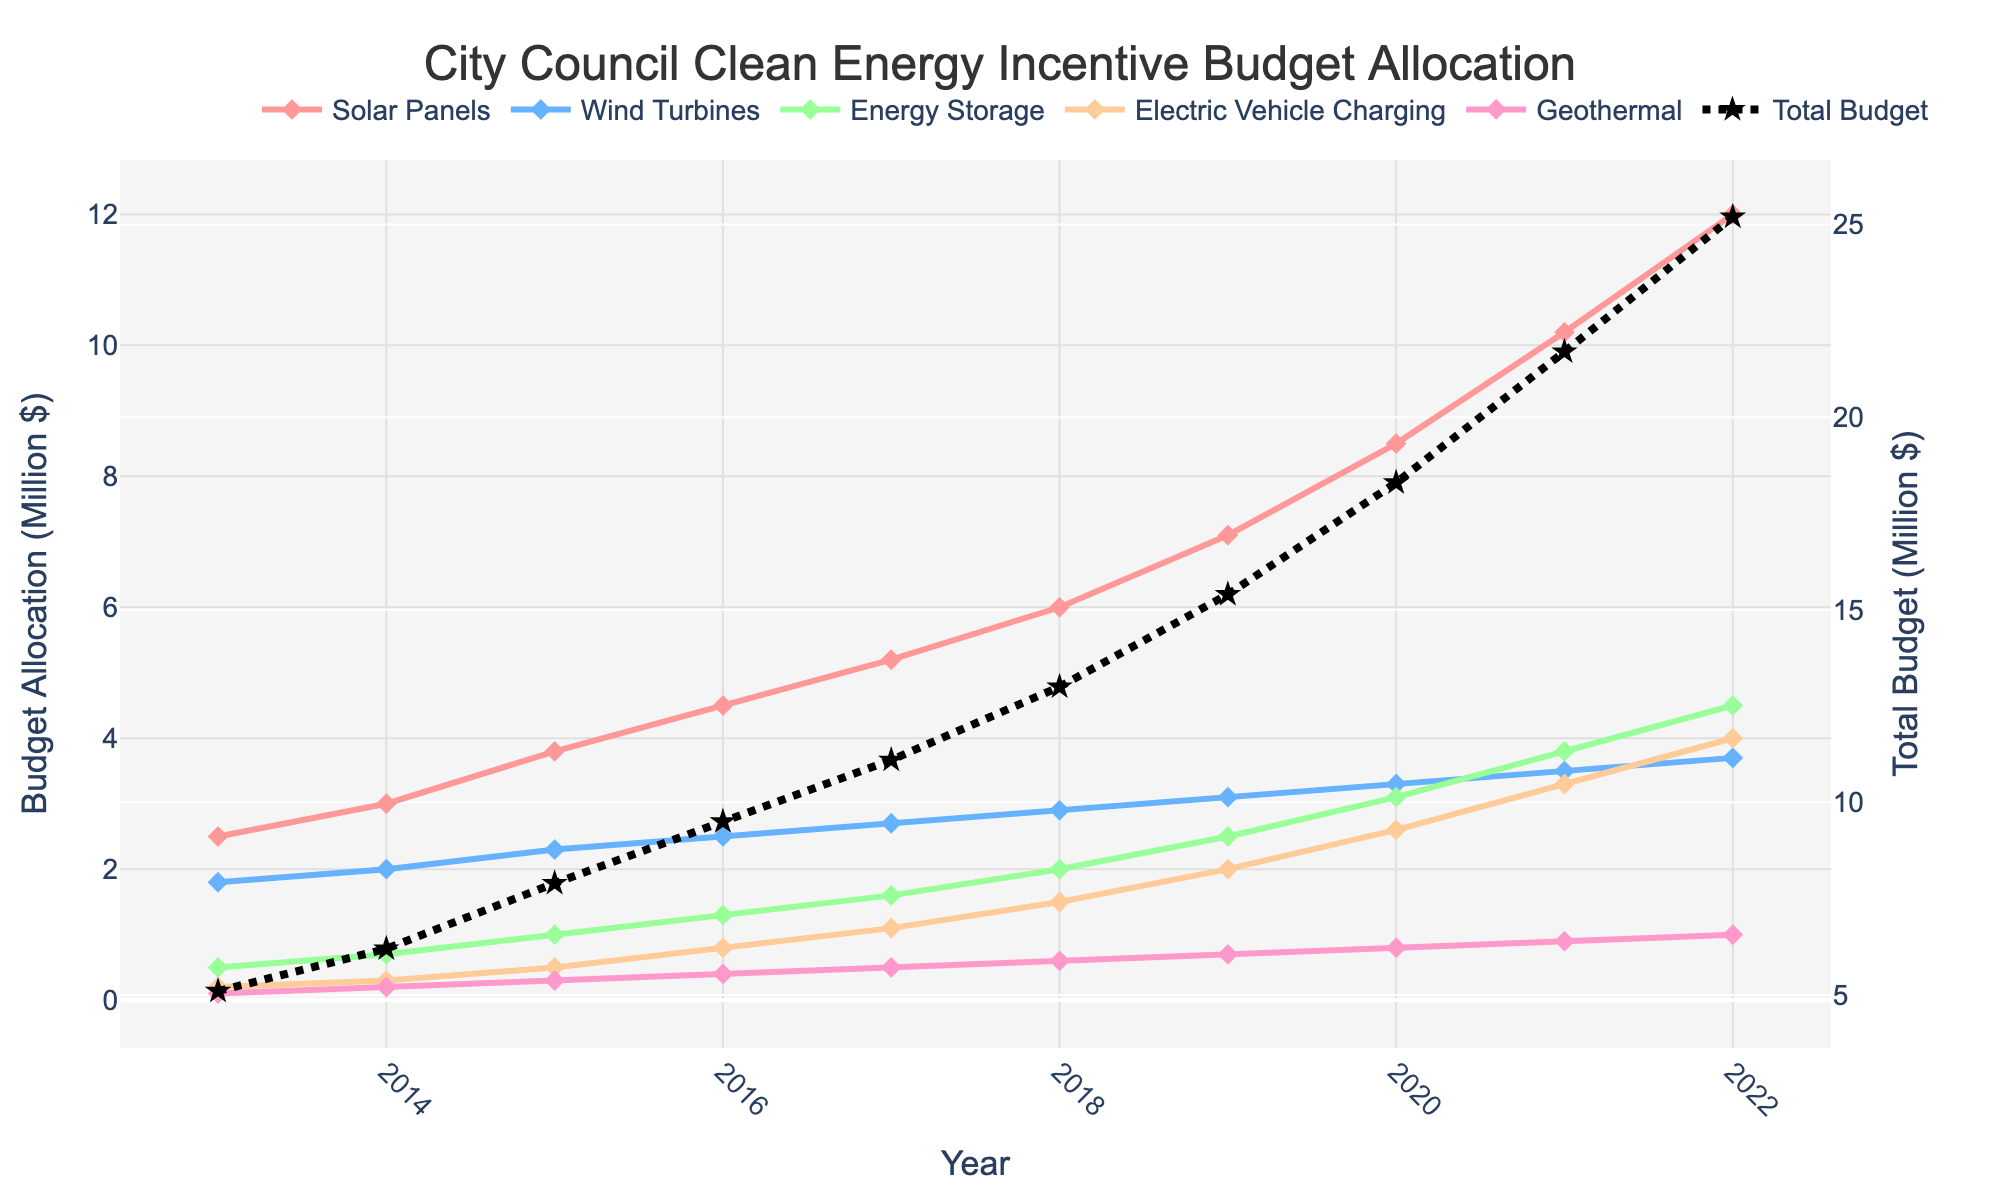What is the highest budget allocation for solar panels over the past decade? The highest budget allocation for solar panels can be identified by looking at the peak point of the solar panels' line, which is in 2022 at $12 million.
Answer: $12 million How much did the total budget increase from 2013 to 2022? The total budget in 2013 was the sum of all technologies that year: 2.5 (Solar Panels) + 1.8 (Wind Turbines) + 0.5 (Energy Storage) + 0.2 (Electric Vehicle Charging) + 0.1 (Geothermal) = 5.1 million dollars. The total budget in 2022 was the sum of all technologies that year: 12.0 (Solar Panels) + 3.7 (Wind Turbines) + 4.5 (Energy Storage) + 4.0 (Electric Vehicle Charging) + 1.0 (Geothermal) = 25.2 million dollars. The increase is 25.2 - 5.1 = 20.1 million dollars.
Answer: $20.1 million Between which two consecutive years was the budget allocation for energy storage the highest? By examining the plot, it can be observed that the largest increase in the energy storage budget occurs between 2019 and 2020 (2.5 million to 3.1 million). The increase is 3.1 - 2.5 = 0.6 million dollars.
Answer: 2019-2020 Comparing the budget allocation for wind turbines and electric vehicle charging in 2019, which had a higher allocation, and by how much? In 2019, the budget for wind turbines was 3.1 million dollars and for electric vehicle charging was 2.0 million dollars. Therefore, wind turbines had a higher allocation by 3.1 - 2.0 = 1.1 million dollars.
Answer: Wind Turbines by $1.1 million What was the average annual budget allocation for geothermal from 2013 to 2022? The annual budget allocations for geothermal from 2013 to 2022 are: 0.1, 0.2, 0.3, 0.4, 0.5, 0.6, 0.7, 0.8, 0.9, and 1.0 million dollars. The sum is 0.1 + 0.2 + 0.3 + 0.4 + 0.5 + 0.6 + 0.7 + 0.8 + 0.9 + 1.0 = 5.5 million dollars. The average annual allocation is 5.5 / 10 = 0.55 million dollars.
Answer: $0.55 million Which technology had the most consistent budget growth over the years, as indicated by nearly uniform increments on the graph? By looking at the slope of the lines, the budget for solar panels showed the most consistent growth, with nearly uniform increments year over year.
Answer: Solar Panels In what year did the total clean energy incentive budget exceed $15 million for the first time? By looking at the dotted line representing the total budget, we see it first exceeds $15 million between 2018 and 2019. It surpasses $15 million definitively in 2019.
Answer: 2019 What is the total budget allocation for electric vehicle charging and geothermal in 2021? The allocation for electric vehicle charging in 2021 was 3.3 million dollars, and for geothermal, it was 0.9 million dollars. The total allocation for both is 3.3 + 0.9 = 4.2 million dollars.
Answer: $4.2 million By how much did the budget for wind turbines change from the lowest to the highest year? The budget for wind turbines was lowest in 2013 at 1.8 million dollars and highest in 2022 at 3.7 million dollars. The change is 3.7 - 1.8 = 1.9 million dollars.
Answer: $1.9 million What was the yearly increment in the solar panel budget from 2018 to 2019, and how does it compare to the increment from 2019 to 2020? From 2018 to 2019, the solar panel budget increased from 6.0 million to 7.1 million dollars, an increment of 1.1 million dollars. From 2019 to 2020, it increased from 7.1 million to 8.5 million dollars, an increment of 1.4 million dollars. Comparing these, the increment from 2019 to 2020 was 1.4 - 1.1 = 0.3 million dollars higher.
Answer: $0.3 million higher 